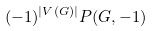Convert formula to latex. <formula><loc_0><loc_0><loc_500><loc_500>( - 1 ) ^ { | V ( G ) | } P ( G , - 1 )</formula> 